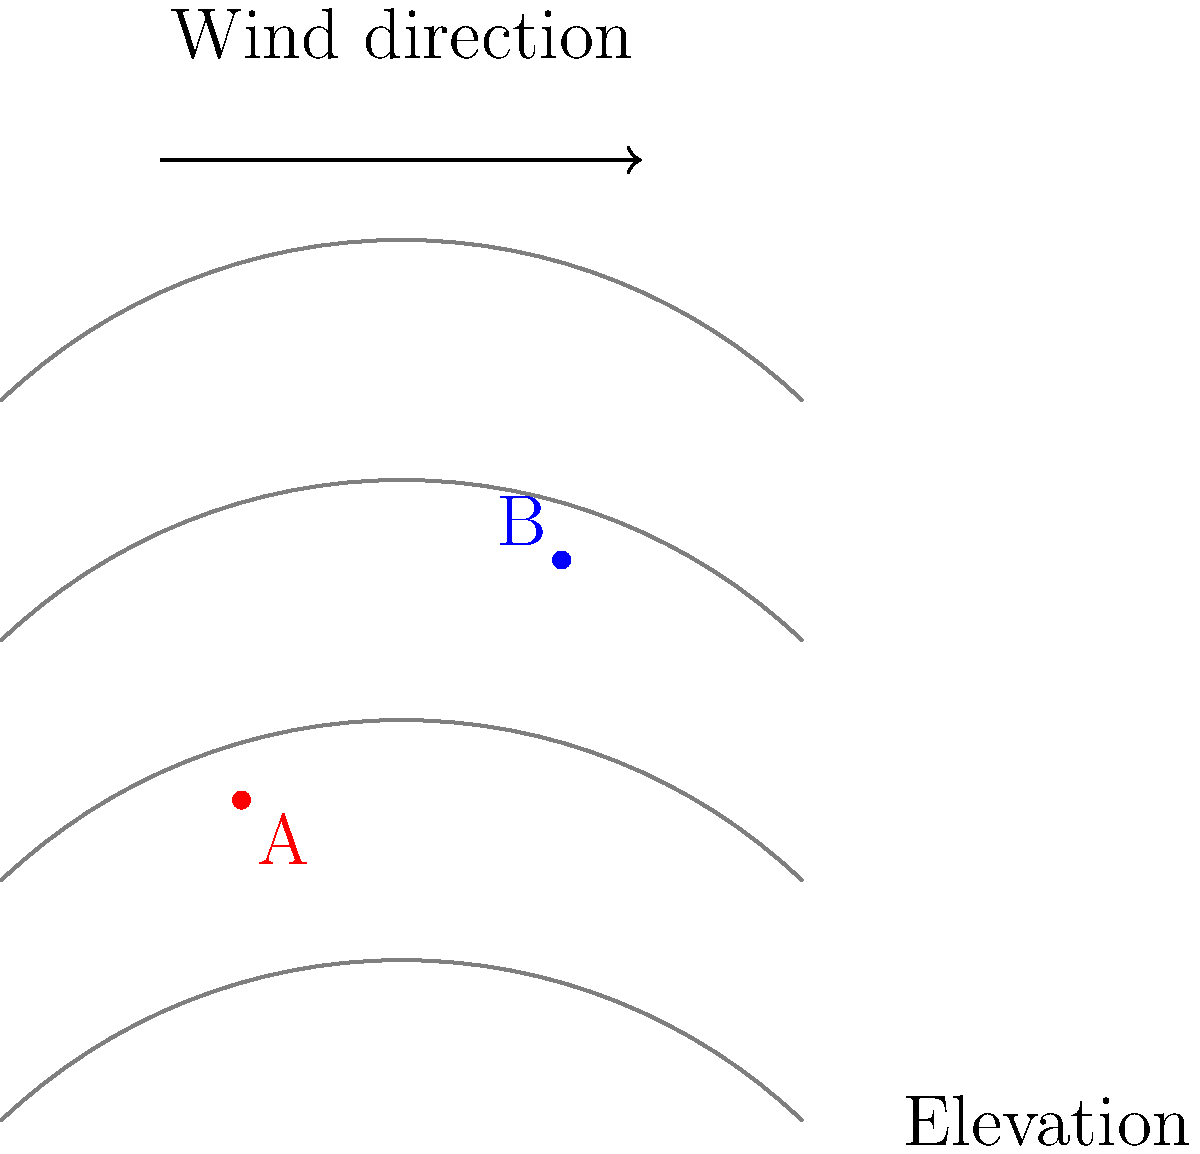Based on the topographical map and wind direction shown, which wind turbine location (A or B) is likely to have higher wind speeds and be more efficient for energy production? Explain your reasoning considering the interaction between wind and terrain. To determine the optimal wind turbine placement, we need to consider how wind interacts with topography:

1. Wind compression: As wind approaches a hill or ridge, it's forced to compress and accelerate over the obstacle.

2. Elevation: Generally, wind speeds increase with height above the ground due to reduced surface friction.

3. Wind direction: The prevailing wind direction is crucial for turbine placement.

Analyzing the map:

1. Wind direction: The arrow indicates wind flowing from left to right.

2. Topography: The contour lines show increasing elevation from bottom to top, with a ridge-like feature in the center.

3. Turbine locations:
   - Turbine A is on the windward side of the ridge at a lower elevation.
   - Turbine B is near the top of the ridge at a higher elevation.

4. Wind-terrain interaction:
   - As the wind approaches the ridge, it will compress and accelerate.
   - The highest wind speeds are typically found just before or at the top of the ridge on the windward side.

5. Comparing locations:
   - Turbine B is positioned to take advantage of both the wind compression effect and higher elevation.
   - Turbine A, while on the windward side, is at a lower elevation and may not benefit as much from the compression effect.

Therefore, Turbine B is likely to experience higher wind speeds and be more efficient for energy production due to its optimal position on the ridge and higher elevation.
Answer: Turbine B 